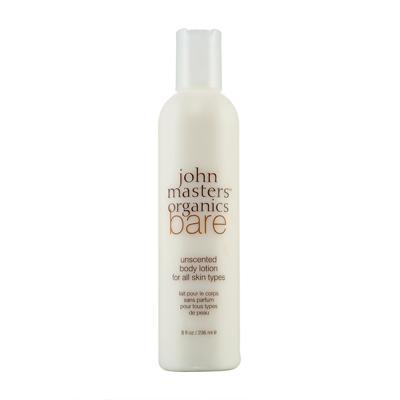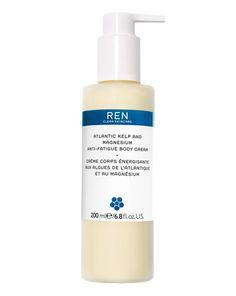The first image is the image on the left, the second image is the image on the right. Considering the images on both sides, is "One of the bottles has a pump dispenser on top." valid? Answer yes or no. Yes. The first image is the image on the left, the second image is the image on the right. For the images shown, is this caption "One of the bottles has a pump cap." true? Answer yes or no. Yes. 